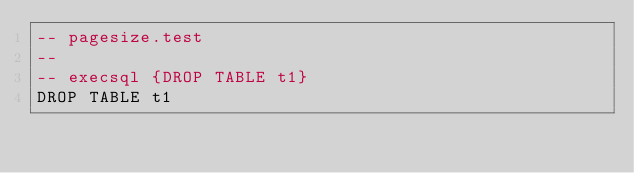Convert code to text. <code><loc_0><loc_0><loc_500><loc_500><_SQL_>-- pagesize.test
-- 
-- execsql {DROP TABLE t1}
DROP TABLE t1</code> 